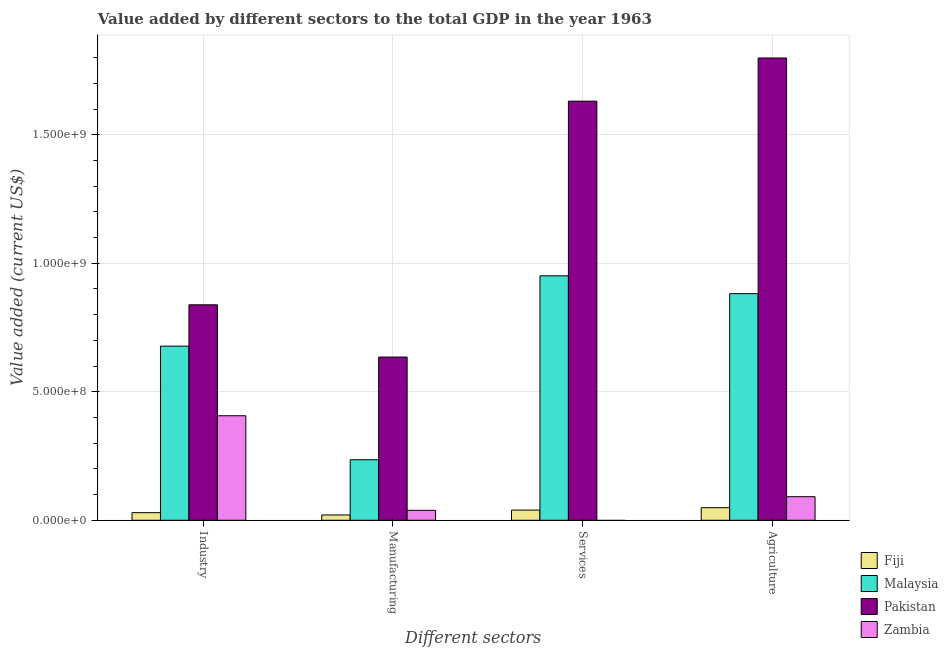How many different coloured bars are there?
Your answer should be compact. 4. How many groups of bars are there?
Make the answer very short. 4. What is the label of the 3rd group of bars from the left?
Provide a succinct answer. Services. What is the value added by manufacturing sector in Pakistan?
Provide a succinct answer. 6.35e+08. Across all countries, what is the maximum value added by services sector?
Give a very brief answer. 1.63e+09. Across all countries, what is the minimum value added by agricultural sector?
Your answer should be very brief. 4.90e+07. In which country was the value added by industrial sector maximum?
Your answer should be very brief. Pakistan. What is the total value added by services sector in the graph?
Make the answer very short. 2.62e+09. What is the difference between the value added by manufacturing sector in Malaysia and that in Zambia?
Ensure brevity in your answer.  1.97e+08. What is the difference between the value added by manufacturing sector in Pakistan and the value added by industrial sector in Zambia?
Keep it short and to the point. 2.28e+08. What is the average value added by services sector per country?
Give a very brief answer. 6.55e+08. What is the difference between the value added by services sector and value added by industrial sector in Fiji?
Provide a short and direct response. 1.01e+07. In how many countries, is the value added by services sector greater than 1000000000 US$?
Your response must be concise. 1. What is the ratio of the value added by manufacturing sector in Pakistan to that in Fiji?
Offer a terse response. 30.75. What is the difference between the highest and the second highest value added by services sector?
Keep it short and to the point. 6.80e+08. What is the difference between the highest and the lowest value added by manufacturing sector?
Provide a short and direct response. 6.14e+08. Is it the case that in every country, the sum of the value added by industrial sector and value added by manufacturing sector is greater than the value added by services sector?
Your answer should be compact. No. Are the values on the major ticks of Y-axis written in scientific E-notation?
Give a very brief answer. Yes. Does the graph contain any zero values?
Offer a terse response. Yes. What is the title of the graph?
Offer a terse response. Value added by different sectors to the total GDP in the year 1963. What is the label or title of the X-axis?
Keep it short and to the point. Different sectors. What is the label or title of the Y-axis?
Make the answer very short. Value added (current US$). What is the Value added (current US$) of Fiji in Industry?
Offer a terse response. 2.96e+07. What is the Value added (current US$) of Malaysia in Industry?
Offer a terse response. 6.77e+08. What is the Value added (current US$) in Pakistan in Industry?
Offer a very short reply. 8.38e+08. What is the Value added (current US$) in Zambia in Industry?
Ensure brevity in your answer.  4.07e+08. What is the Value added (current US$) of Fiji in Manufacturing?
Offer a terse response. 2.07e+07. What is the Value added (current US$) of Malaysia in Manufacturing?
Make the answer very short. 2.36e+08. What is the Value added (current US$) of Pakistan in Manufacturing?
Provide a succinct answer. 6.35e+08. What is the Value added (current US$) of Zambia in Manufacturing?
Offer a terse response. 3.86e+07. What is the Value added (current US$) in Fiji in Services?
Provide a succinct answer. 3.97e+07. What is the Value added (current US$) in Malaysia in Services?
Offer a very short reply. 9.51e+08. What is the Value added (current US$) in Pakistan in Services?
Your answer should be very brief. 1.63e+09. What is the Value added (current US$) of Fiji in Agriculture?
Your answer should be compact. 4.90e+07. What is the Value added (current US$) of Malaysia in Agriculture?
Offer a very short reply. 8.82e+08. What is the Value added (current US$) of Pakistan in Agriculture?
Offer a terse response. 1.80e+09. What is the Value added (current US$) in Zambia in Agriculture?
Your answer should be very brief. 9.17e+07. Across all Different sectors, what is the maximum Value added (current US$) of Fiji?
Ensure brevity in your answer.  4.90e+07. Across all Different sectors, what is the maximum Value added (current US$) of Malaysia?
Your answer should be compact. 9.51e+08. Across all Different sectors, what is the maximum Value added (current US$) in Pakistan?
Your answer should be very brief. 1.80e+09. Across all Different sectors, what is the maximum Value added (current US$) of Zambia?
Offer a very short reply. 4.07e+08. Across all Different sectors, what is the minimum Value added (current US$) in Fiji?
Your response must be concise. 2.07e+07. Across all Different sectors, what is the minimum Value added (current US$) in Malaysia?
Make the answer very short. 2.36e+08. Across all Different sectors, what is the minimum Value added (current US$) in Pakistan?
Your answer should be compact. 6.35e+08. What is the total Value added (current US$) in Fiji in the graph?
Provide a succinct answer. 1.39e+08. What is the total Value added (current US$) in Malaysia in the graph?
Provide a succinct answer. 2.75e+09. What is the total Value added (current US$) of Pakistan in the graph?
Ensure brevity in your answer.  4.90e+09. What is the total Value added (current US$) in Zambia in the graph?
Provide a short and direct response. 5.37e+08. What is the difference between the Value added (current US$) in Fiji in Industry and that in Manufacturing?
Your answer should be compact. 8.94e+06. What is the difference between the Value added (current US$) of Malaysia in Industry and that in Manufacturing?
Your answer should be very brief. 4.42e+08. What is the difference between the Value added (current US$) in Pakistan in Industry and that in Manufacturing?
Provide a short and direct response. 2.03e+08. What is the difference between the Value added (current US$) of Zambia in Industry and that in Manufacturing?
Make the answer very short. 3.68e+08. What is the difference between the Value added (current US$) in Fiji in Industry and that in Services?
Offer a terse response. -1.01e+07. What is the difference between the Value added (current US$) of Malaysia in Industry and that in Services?
Your answer should be very brief. -2.74e+08. What is the difference between the Value added (current US$) in Pakistan in Industry and that in Services?
Provide a succinct answer. -7.92e+08. What is the difference between the Value added (current US$) of Fiji in Industry and that in Agriculture?
Your answer should be very brief. -1.94e+07. What is the difference between the Value added (current US$) in Malaysia in Industry and that in Agriculture?
Give a very brief answer. -2.04e+08. What is the difference between the Value added (current US$) of Pakistan in Industry and that in Agriculture?
Give a very brief answer. -9.60e+08. What is the difference between the Value added (current US$) of Zambia in Industry and that in Agriculture?
Offer a terse response. 3.15e+08. What is the difference between the Value added (current US$) of Fiji in Manufacturing and that in Services?
Ensure brevity in your answer.  -1.90e+07. What is the difference between the Value added (current US$) of Malaysia in Manufacturing and that in Services?
Provide a succinct answer. -7.15e+08. What is the difference between the Value added (current US$) of Pakistan in Manufacturing and that in Services?
Give a very brief answer. -9.96e+08. What is the difference between the Value added (current US$) of Fiji in Manufacturing and that in Agriculture?
Provide a succinct answer. -2.83e+07. What is the difference between the Value added (current US$) in Malaysia in Manufacturing and that in Agriculture?
Ensure brevity in your answer.  -6.46e+08. What is the difference between the Value added (current US$) of Pakistan in Manufacturing and that in Agriculture?
Make the answer very short. -1.16e+09. What is the difference between the Value added (current US$) of Zambia in Manufacturing and that in Agriculture?
Make the answer very short. -5.31e+07. What is the difference between the Value added (current US$) of Fiji in Services and that in Agriculture?
Your answer should be compact. -9.32e+06. What is the difference between the Value added (current US$) in Malaysia in Services and that in Agriculture?
Offer a very short reply. 6.94e+07. What is the difference between the Value added (current US$) of Pakistan in Services and that in Agriculture?
Ensure brevity in your answer.  -1.68e+08. What is the difference between the Value added (current US$) of Fiji in Industry and the Value added (current US$) of Malaysia in Manufacturing?
Provide a short and direct response. -2.06e+08. What is the difference between the Value added (current US$) in Fiji in Industry and the Value added (current US$) in Pakistan in Manufacturing?
Provide a short and direct response. -6.05e+08. What is the difference between the Value added (current US$) of Fiji in Industry and the Value added (current US$) of Zambia in Manufacturing?
Your answer should be very brief. -9.05e+06. What is the difference between the Value added (current US$) of Malaysia in Industry and the Value added (current US$) of Pakistan in Manufacturing?
Make the answer very short. 4.24e+07. What is the difference between the Value added (current US$) of Malaysia in Industry and the Value added (current US$) of Zambia in Manufacturing?
Keep it short and to the point. 6.39e+08. What is the difference between the Value added (current US$) in Pakistan in Industry and the Value added (current US$) in Zambia in Manufacturing?
Provide a succinct answer. 8.00e+08. What is the difference between the Value added (current US$) in Fiji in Industry and the Value added (current US$) in Malaysia in Services?
Offer a very short reply. -9.21e+08. What is the difference between the Value added (current US$) of Fiji in Industry and the Value added (current US$) of Pakistan in Services?
Ensure brevity in your answer.  -1.60e+09. What is the difference between the Value added (current US$) in Malaysia in Industry and the Value added (current US$) in Pakistan in Services?
Your answer should be very brief. -9.53e+08. What is the difference between the Value added (current US$) of Fiji in Industry and the Value added (current US$) of Malaysia in Agriculture?
Give a very brief answer. -8.52e+08. What is the difference between the Value added (current US$) in Fiji in Industry and the Value added (current US$) in Pakistan in Agriculture?
Make the answer very short. -1.77e+09. What is the difference between the Value added (current US$) of Fiji in Industry and the Value added (current US$) of Zambia in Agriculture?
Offer a very short reply. -6.21e+07. What is the difference between the Value added (current US$) of Malaysia in Industry and the Value added (current US$) of Pakistan in Agriculture?
Ensure brevity in your answer.  -1.12e+09. What is the difference between the Value added (current US$) of Malaysia in Industry and the Value added (current US$) of Zambia in Agriculture?
Provide a short and direct response. 5.86e+08. What is the difference between the Value added (current US$) in Pakistan in Industry and the Value added (current US$) in Zambia in Agriculture?
Ensure brevity in your answer.  7.47e+08. What is the difference between the Value added (current US$) in Fiji in Manufacturing and the Value added (current US$) in Malaysia in Services?
Make the answer very short. -9.30e+08. What is the difference between the Value added (current US$) of Fiji in Manufacturing and the Value added (current US$) of Pakistan in Services?
Offer a very short reply. -1.61e+09. What is the difference between the Value added (current US$) in Malaysia in Manufacturing and the Value added (current US$) in Pakistan in Services?
Give a very brief answer. -1.40e+09. What is the difference between the Value added (current US$) in Fiji in Manufacturing and the Value added (current US$) in Malaysia in Agriculture?
Your response must be concise. -8.61e+08. What is the difference between the Value added (current US$) of Fiji in Manufacturing and the Value added (current US$) of Pakistan in Agriculture?
Keep it short and to the point. -1.78e+09. What is the difference between the Value added (current US$) of Fiji in Manufacturing and the Value added (current US$) of Zambia in Agriculture?
Provide a short and direct response. -7.10e+07. What is the difference between the Value added (current US$) in Malaysia in Manufacturing and the Value added (current US$) in Pakistan in Agriculture?
Your response must be concise. -1.56e+09. What is the difference between the Value added (current US$) in Malaysia in Manufacturing and the Value added (current US$) in Zambia in Agriculture?
Offer a very short reply. 1.44e+08. What is the difference between the Value added (current US$) of Pakistan in Manufacturing and the Value added (current US$) of Zambia in Agriculture?
Your response must be concise. 5.43e+08. What is the difference between the Value added (current US$) of Fiji in Services and the Value added (current US$) of Malaysia in Agriculture?
Your answer should be compact. -8.42e+08. What is the difference between the Value added (current US$) of Fiji in Services and the Value added (current US$) of Pakistan in Agriculture?
Your answer should be very brief. -1.76e+09. What is the difference between the Value added (current US$) in Fiji in Services and the Value added (current US$) in Zambia in Agriculture?
Offer a terse response. -5.20e+07. What is the difference between the Value added (current US$) of Malaysia in Services and the Value added (current US$) of Pakistan in Agriculture?
Give a very brief answer. -8.48e+08. What is the difference between the Value added (current US$) in Malaysia in Services and the Value added (current US$) in Zambia in Agriculture?
Ensure brevity in your answer.  8.59e+08. What is the difference between the Value added (current US$) of Pakistan in Services and the Value added (current US$) of Zambia in Agriculture?
Keep it short and to the point. 1.54e+09. What is the average Value added (current US$) in Fiji per Different sectors?
Ensure brevity in your answer.  3.47e+07. What is the average Value added (current US$) of Malaysia per Different sectors?
Give a very brief answer. 6.86e+08. What is the average Value added (current US$) of Pakistan per Different sectors?
Ensure brevity in your answer.  1.23e+09. What is the average Value added (current US$) of Zambia per Different sectors?
Provide a succinct answer. 1.34e+08. What is the difference between the Value added (current US$) in Fiji and Value added (current US$) in Malaysia in Industry?
Keep it short and to the point. -6.48e+08. What is the difference between the Value added (current US$) in Fiji and Value added (current US$) in Pakistan in Industry?
Your response must be concise. -8.09e+08. What is the difference between the Value added (current US$) in Fiji and Value added (current US$) in Zambia in Industry?
Offer a terse response. -3.77e+08. What is the difference between the Value added (current US$) of Malaysia and Value added (current US$) of Pakistan in Industry?
Give a very brief answer. -1.61e+08. What is the difference between the Value added (current US$) in Malaysia and Value added (current US$) in Zambia in Industry?
Provide a succinct answer. 2.71e+08. What is the difference between the Value added (current US$) of Pakistan and Value added (current US$) of Zambia in Industry?
Make the answer very short. 4.32e+08. What is the difference between the Value added (current US$) in Fiji and Value added (current US$) in Malaysia in Manufacturing?
Ensure brevity in your answer.  -2.15e+08. What is the difference between the Value added (current US$) in Fiji and Value added (current US$) in Pakistan in Manufacturing?
Your answer should be very brief. -6.14e+08. What is the difference between the Value added (current US$) in Fiji and Value added (current US$) in Zambia in Manufacturing?
Keep it short and to the point. -1.80e+07. What is the difference between the Value added (current US$) in Malaysia and Value added (current US$) in Pakistan in Manufacturing?
Your response must be concise. -3.99e+08. What is the difference between the Value added (current US$) in Malaysia and Value added (current US$) in Zambia in Manufacturing?
Keep it short and to the point. 1.97e+08. What is the difference between the Value added (current US$) in Pakistan and Value added (current US$) in Zambia in Manufacturing?
Give a very brief answer. 5.96e+08. What is the difference between the Value added (current US$) of Fiji and Value added (current US$) of Malaysia in Services?
Keep it short and to the point. -9.11e+08. What is the difference between the Value added (current US$) in Fiji and Value added (current US$) in Pakistan in Services?
Make the answer very short. -1.59e+09. What is the difference between the Value added (current US$) of Malaysia and Value added (current US$) of Pakistan in Services?
Provide a succinct answer. -6.80e+08. What is the difference between the Value added (current US$) of Fiji and Value added (current US$) of Malaysia in Agriculture?
Offer a very short reply. -8.33e+08. What is the difference between the Value added (current US$) of Fiji and Value added (current US$) of Pakistan in Agriculture?
Offer a very short reply. -1.75e+09. What is the difference between the Value added (current US$) in Fiji and Value added (current US$) in Zambia in Agriculture?
Ensure brevity in your answer.  -4.27e+07. What is the difference between the Value added (current US$) in Malaysia and Value added (current US$) in Pakistan in Agriculture?
Offer a terse response. -9.17e+08. What is the difference between the Value added (current US$) in Malaysia and Value added (current US$) in Zambia in Agriculture?
Offer a very short reply. 7.90e+08. What is the difference between the Value added (current US$) in Pakistan and Value added (current US$) in Zambia in Agriculture?
Offer a very short reply. 1.71e+09. What is the ratio of the Value added (current US$) of Fiji in Industry to that in Manufacturing?
Make the answer very short. 1.43. What is the ratio of the Value added (current US$) of Malaysia in Industry to that in Manufacturing?
Ensure brevity in your answer.  2.88. What is the ratio of the Value added (current US$) in Pakistan in Industry to that in Manufacturing?
Offer a very short reply. 1.32. What is the ratio of the Value added (current US$) of Zambia in Industry to that in Manufacturing?
Offer a very short reply. 10.53. What is the ratio of the Value added (current US$) of Fiji in Industry to that in Services?
Offer a very short reply. 0.75. What is the ratio of the Value added (current US$) in Malaysia in Industry to that in Services?
Your answer should be very brief. 0.71. What is the ratio of the Value added (current US$) of Pakistan in Industry to that in Services?
Keep it short and to the point. 0.51. What is the ratio of the Value added (current US$) of Fiji in Industry to that in Agriculture?
Your response must be concise. 0.6. What is the ratio of the Value added (current US$) of Malaysia in Industry to that in Agriculture?
Keep it short and to the point. 0.77. What is the ratio of the Value added (current US$) in Pakistan in Industry to that in Agriculture?
Make the answer very short. 0.47. What is the ratio of the Value added (current US$) of Zambia in Industry to that in Agriculture?
Make the answer very short. 4.44. What is the ratio of the Value added (current US$) in Fiji in Manufacturing to that in Services?
Provide a succinct answer. 0.52. What is the ratio of the Value added (current US$) of Malaysia in Manufacturing to that in Services?
Provide a short and direct response. 0.25. What is the ratio of the Value added (current US$) in Pakistan in Manufacturing to that in Services?
Ensure brevity in your answer.  0.39. What is the ratio of the Value added (current US$) in Fiji in Manufacturing to that in Agriculture?
Provide a succinct answer. 0.42. What is the ratio of the Value added (current US$) of Malaysia in Manufacturing to that in Agriculture?
Offer a terse response. 0.27. What is the ratio of the Value added (current US$) in Pakistan in Manufacturing to that in Agriculture?
Offer a very short reply. 0.35. What is the ratio of the Value added (current US$) in Zambia in Manufacturing to that in Agriculture?
Provide a short and direct response. 0.42. What is the ratio of the Value added (current US$) in Fiji in Services to that in Agriculture?
Offer a terse response. 0.81. What is the ratio of the Value added (current US$) of Malaysia in Services to that in Agriculture?
Keep it short and to the point. 1.08. What is the ratio of the Value added (current US$) of Pakistan in Services to that in Agriculture?
Provide a succinct answer. 0.91. What is the difference between the highest and the second highest Value added (current US$) of Fiji?
Offer a terse response. 9.32e+06. What is the difference between the highest and the second highest Value added (current US$) of Malaysia?
Your answer should be compact. 6.94e+07. What is the difference between the highest and the second highest Value added (current US$) in Pakistan?
Provide a short and direct response. 1.68e+08. What is the difference between the highest and the second highest Value added (current US$) in Zambia?
Give a very brief answer. 3.15e+08. What is the difference between the highest and the lowest Value added (current US$) of Fiji?
Make the answer very short. 2.83e+07. What is the difference between the highest and the lowest Value added (current US$) of Malaysia?
Your response must be concise. 7.15e+08. What is the difference between the highest and the lowest Value added (current US$) in Pakistan?
Your answer should be very brief. 1.16e+09. What is the difference between the highest and the lowest Value added (current US$) of Zambia?
Ensure brevity in your answer.  4.07e+08. 